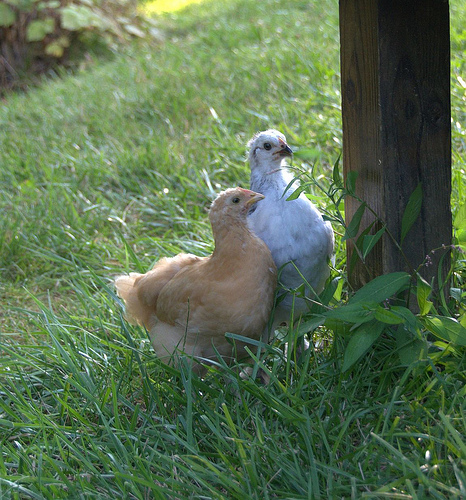<image>
Is there a beak on the bird? No. The beak is not positioned on the bird. They may be near each other, but the beak is not supported by or resting on top of the bird. Where is the bird in relation to the wood? Is it in front of the wood? Yes. The bird is positioned in front of the wood, appearing closer to the camera viewpoint. 